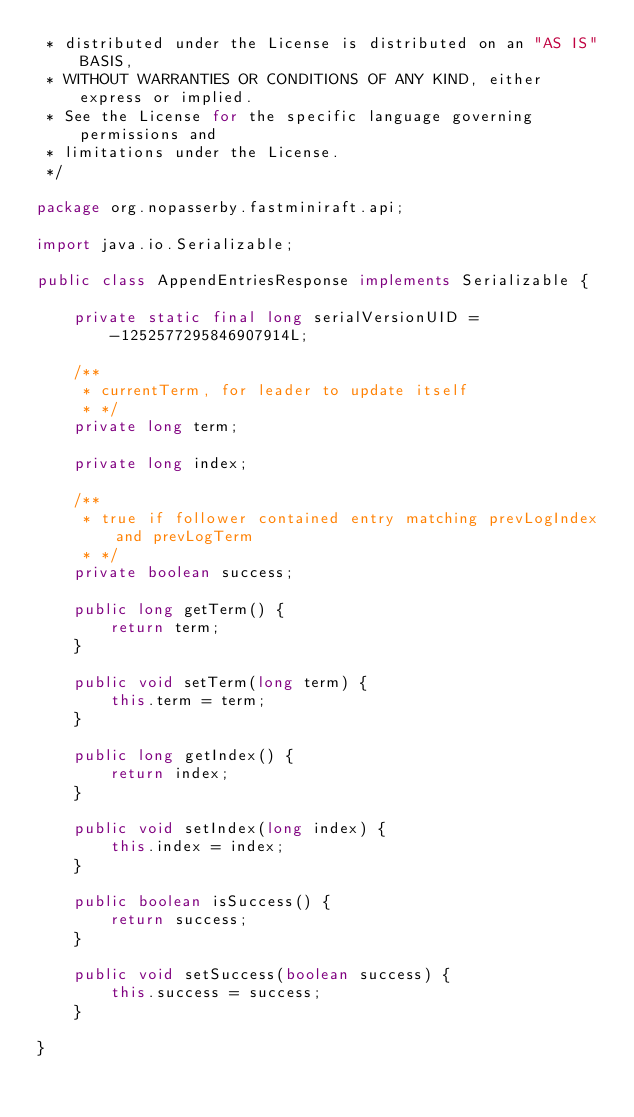<code> <loc_0><loc_0><loc_500><loc_500><_Java_> * distributed under the License is distributed on an "AS IS" BASIS,
 * WITHOUT WARRANTIES OR CONDITIONS OF ANY KIND, either express or implied.
 * See the License for the specific language governing permissions and
 * limitations under the License.
 */

package org.nopasserby.fastminiraft.api;

import java.io.Serializable;

public class AppendEntriesResponse implements Serializable {

    private static final long serialVersionUID = -1252577295846907914L;
    
    /**
     * currentTerm, for leader to update itself
     * */
    private long term;
    
    private long index;
    
    /**
     * true if follower contained entry matching prevLogIndex and prevLogTerm
     * */
    private boolean success;

    public long getTerm() {
        return term;
    }

    public void setTerm(long term) {
        this.term = term;
    }
    
    public long getIndex() {
        return index;
    }

    public void setIndex(long index) {
        this.index = index;
    }

    public boolean isSuccess() {
        return success;
    }

    public void setSuccess(boolean success) {
        this.success = success;
    }
    
}
</code> 